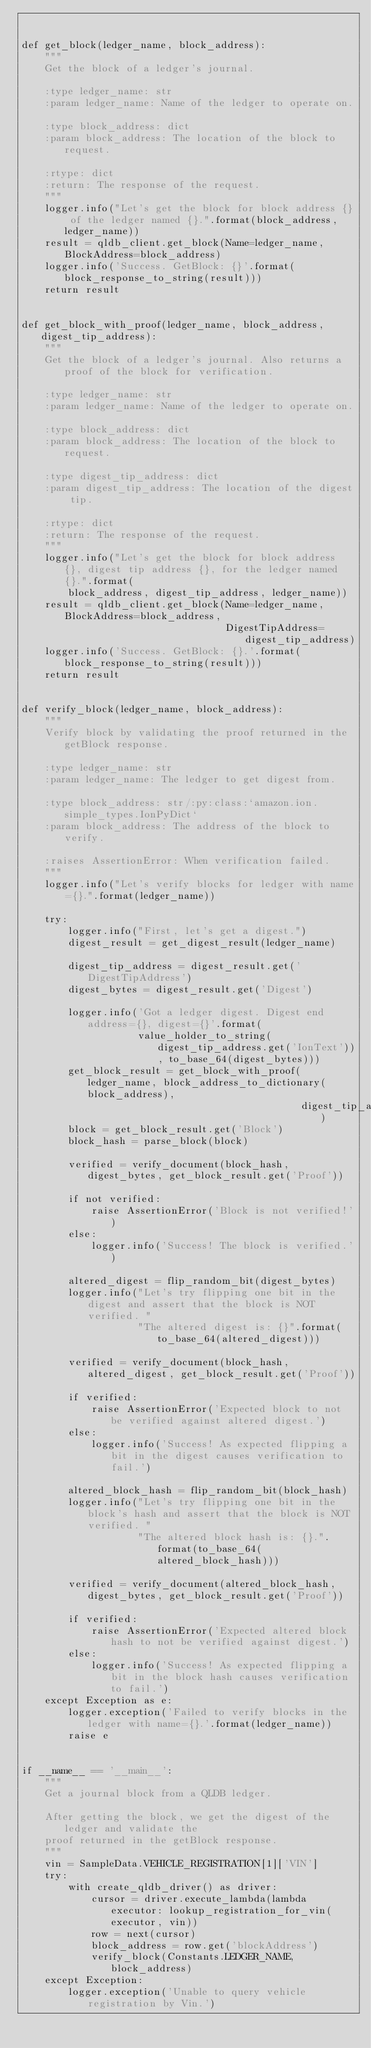Convert code to text. <code><loc_0><loc_0><loc_500><loc_500><_Python_>

def get_block(ledger_name, block_address):
    """
    Get the block of a ledger's journal.

    :type ledger_name: str
    :param ledger_name: Name of the ledger to operate on.

    :type block_address: dict
    :param block_address: The location of the block to request.

    :rtype: dict
    :return: The response of the request.
    """
    logger.info("Let's get the block for block address {} of the ledger named {}.".format(block_address, ledger_name))
    result = qldb_client.get_block(Name=ledger_name, BlockAddress=block_address)
    logger.info('Success. GetBlock: {}'.format(block_response_to_string(result)))
    return result


def get_block_with_proof(ledger_name, block_address, digest_tip_address):
    """
    Get the block of a ledger's journal. Also returns a proof of the block for verification.

    :type ledger_name: str
    :param ledger_name: Name of the ledger to operate on.

    :type block_address: dict
    :param block_address: The location of the block to request.

    :type digest_tip_address: dict
    :param digest_tip_address: The location of the digest tip.

    :rtype: dict
    :return: The response of the request.
    """
    logger.info("Let's get the block for block address {}, digest tip address {}, for the ledger named {}.".format(
        block_address, digest_tip_address, ledger_name))
    result = qldb_client.get_block(Name=ledger_name, BlockAddress=block_address,
                                   DigestTipAddress=digest_tip_address)
    logger.info('Success. GetBlock: {}.'.format(block_response_to_string(result)))
    return result


def verify_block(ledger_name, block_address):
    """
    Verify block by validating the proof returned in the getBlock response.

    :type ledger_name: str
    :param ledger_name: The ledger to get digest from.

    :type block_address: str/:py:class:`amazon.ion.simple_types.IonPyDict`
    :param block_address: The address of the block to verify.

    :raises AssertionError: When verification failed.
    """
    logger.info("Let's verify blocks for ledger with name={}.".format(ledger_name))

    try:
        logger.info("First, let's get a digest.")
        digest_result = get_digest_result(ledger_name)

        digest_tip_address = digest_result.get('DigestTipAddress')
        digest_bytes = digest_result.get('Digest')

        logger.info('Got a ledger digest. Digest end address={}, digest={}'.format(
                    value_holder_to_string(digest_tip_address.get('IonText')), to_base_64(digest_bytes)))
        get_block_result = get_block_with_proof(ledger_name, block_address_to_dictionary(block_address),
                                                digest_tip_address)
        block = get_block_result.get('Block')
        block_hash = parse_block(block)

        verified = verify_document(block_hash, digest_bytes, get_block_result.get('Proof'))

        if not verified:
            raise AssertionError('Block is not verified!')
        else:
            logger.info('Success! The block is verified.')

        altered_digest = flip_random_bit(digest_bytes)
        logger.info("Let's try flipping one bit in the digest and assert that the block is NOT verified. "
                    "The altered digest is: {}".format(to_base_64(altered_digest)))

        verified = verify_document(block_hash, altered_digest, get_block_result.get('Proof'))

        if verified:
            raise AssertionError('Expected block to not be verified against altered digest.')
        else:
            logger.info('Success! As expected flipping a bit in the digest causes verification to fail.')

        altered_block_hash = flip_random_bit(block_hash)
        logger.info("Let's try flipping one bit in the block's hash and assert that the block is NOT verified. "
                    "The altered block hash is: {}.".format(to_base_64(altered_block_hash)))

        verified = verify_document(altered_block_hash, digest_bytes, get_block_result.get('Proof'))

        if verified:
            raise AssertionError('Expected altered block hash to not be verified against digest.')
        else:
            logger.info('Success! As expected flipping a bit in the block hash causes verification to fail.')
    except Exception as e:
        logger.exception('Failed to verify blocks in the ledger with name={}.'.format(ledger_name))
        raise e


if __name__ == '__main__':
    """
    Get a journal block from a QLDB ledger.

    After getting the block, we get the digest of the ledger and validate the
    proof returned in the getBlock response.
    """
    vin = SampleData.VEHICLE_REGISTRATION[1]['VIN']
    try:
        with create_qldb_driver() as driver:
            cursor = driver.execute_lambda(lambda executor: lookup_registration_for_vin(executor, vin))
            row = next(cursor)
            block_address = row.get('blockAddress')
            verify_block(Constants.LEDGER_NAME, block_address)
    except Exception:
        logger.exception('Unable to query vehicle registration by Vin.')
</code> 